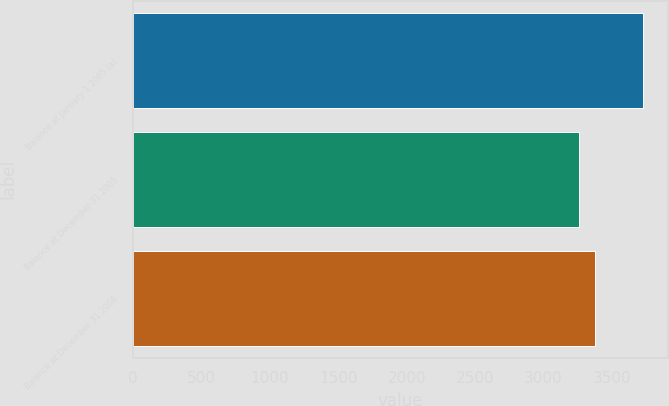<chart> <loc_0><loc_0><loc_500><loc_500><bar_chart><fcel>Balance at January 1 2005 (a)<fcel>Balance at December 31 2005<fcel>Balance at December 31 2006<nl><fcel>3724<fcel>3256<fcel>3377<nl></chart> 